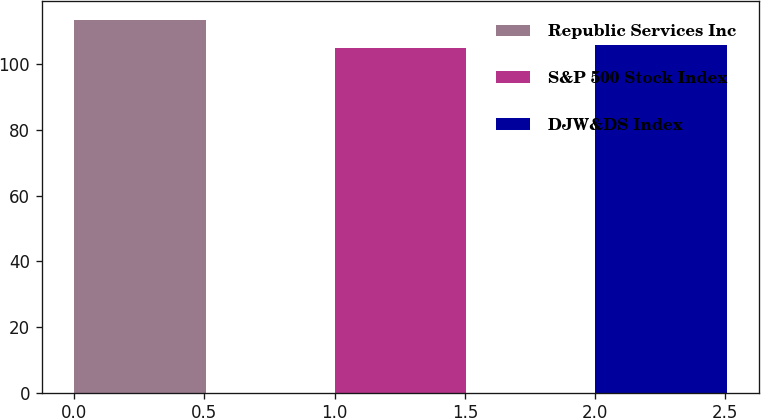<chart> <loc_0><loc_0><loc_500><loc_500><bar_chart><fcel>Republic Services Inc<fcel>S&P 500 Stock Index<fcel>DJW&DS Index<nl><fcel>113.61<fcel>104.91<fcel>106.06<nl></chart> 